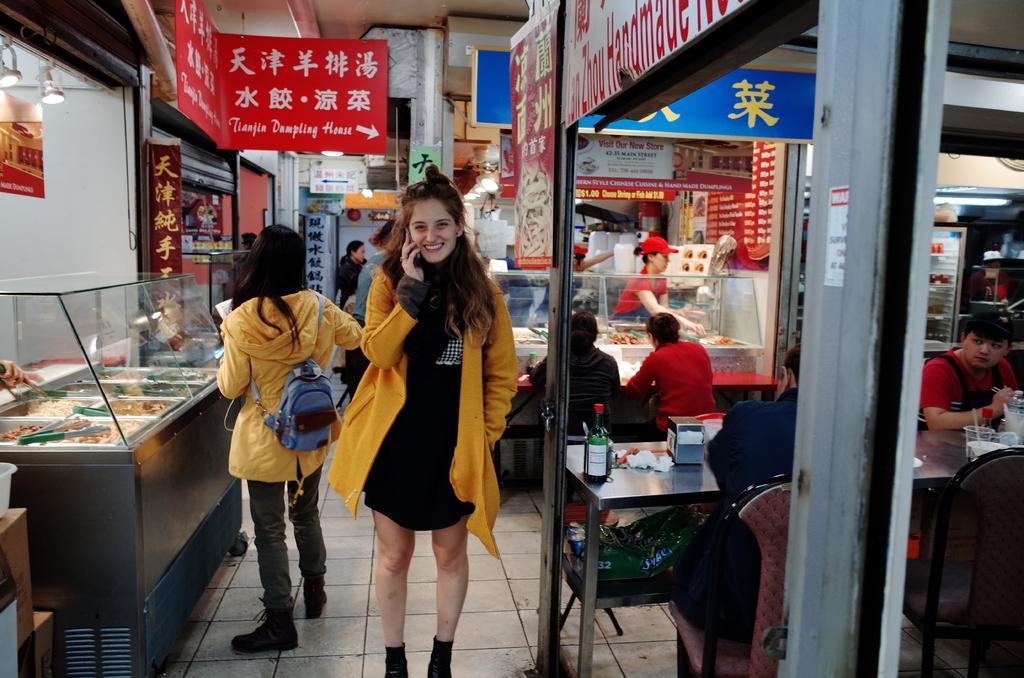Could you give a brief overview of what you see in this image? In the middle a beautiful woman is standing and speaking in the cell phone, she wore yellow color coat. It looks like a restaurant, on the right side few people are sitting on the chairs. There is a dining table. 